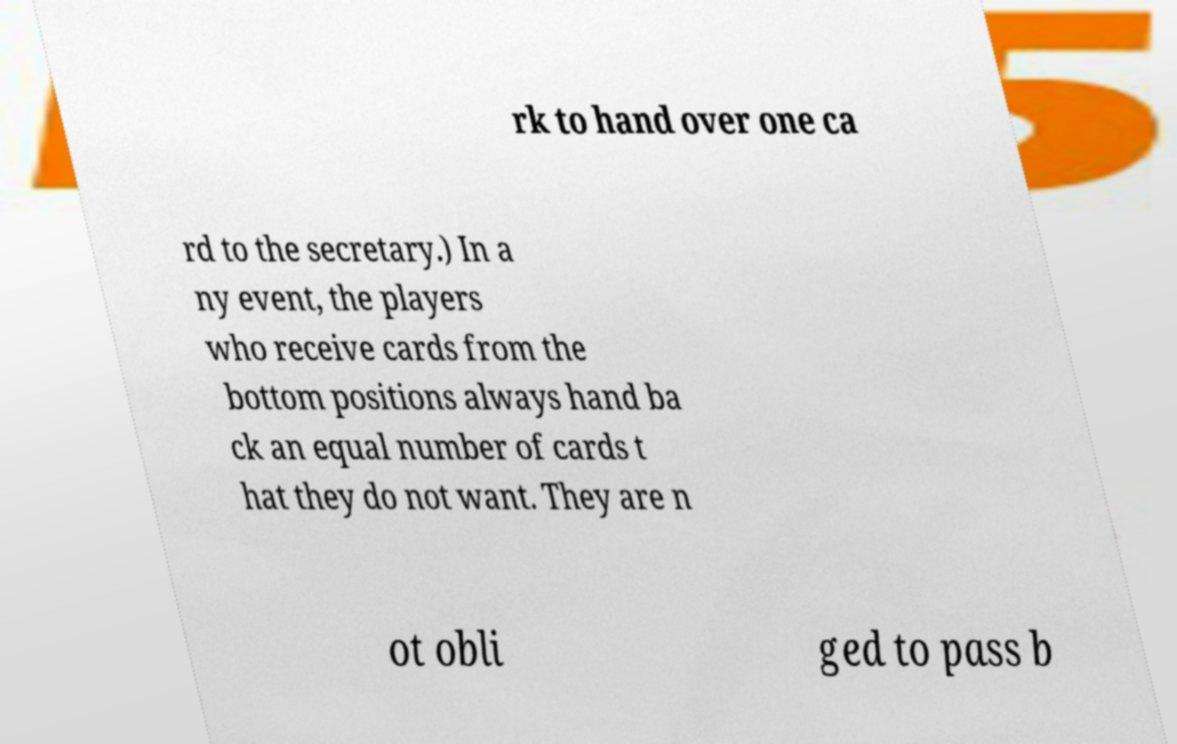There's text embedded in this image that I need extracted. Can you transcribe it verbatim? rk to hand over one ca rd to the secretary.) In a ny event, the players who receive cards from the bottom positions always hand ba ck an equal number of cards t hat they do not want. They are n ot obli ged to pass b 